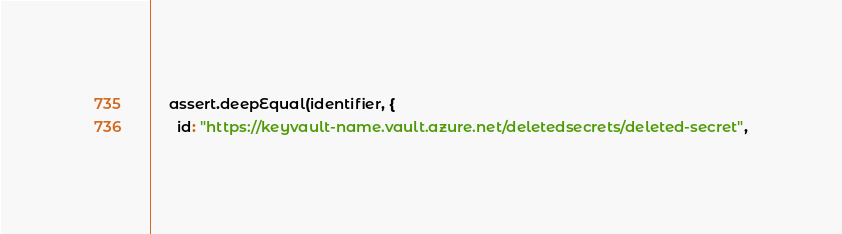Convert code to text. <code><loc_0><loc_0><loc_500><loc_500><_TypeScript_>
    assert.deepEqual(identifier, {
      id: "https://keyvault-name.vault.azure.net/deletedsecrets/deleted-secret",</code> 